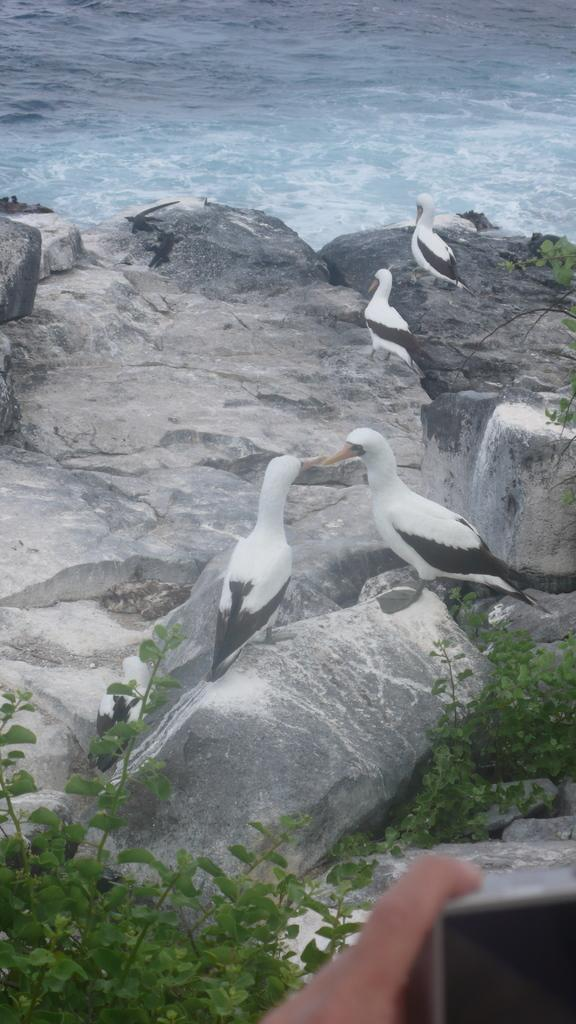What type of natural formation can be seen in the image? There are rocks in the image. What animals are present on the rocks? There are birds on the rocks. Can you describe the person's hand in the image? There is a person's hand holding an object in the image. What can be seen at the top of the image? There is water visible at the top of the image. What type of shop can be seen in the image? There is no shop present in the image; it features rocks, birds, a person's hand, and water. How does the wave affect the rocks in the image? There is no wave present in the image; it features rocks, birds, a person's hand, and water. 